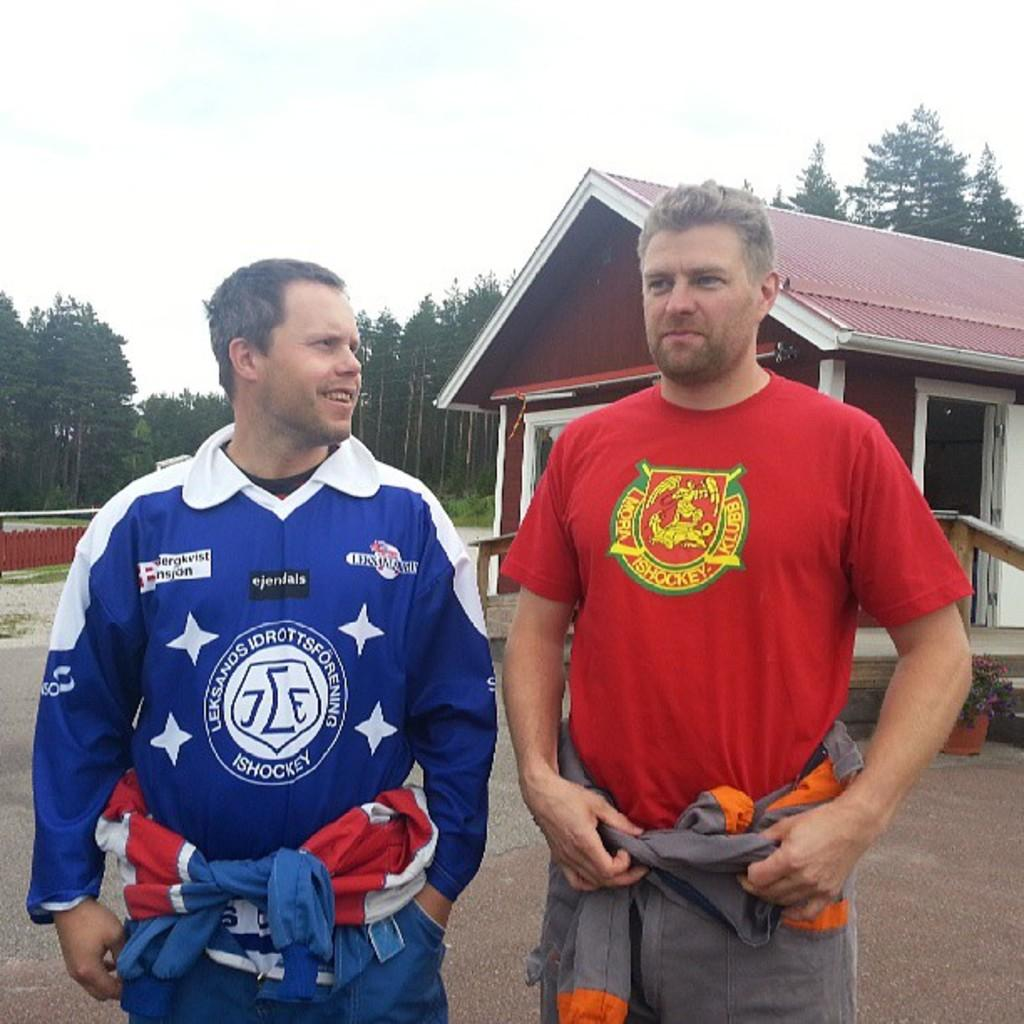<image>
Offer a succinct explanation of the picture presented. Two men are standing next to each other and the taller of the two has a Mora Ishockey Klubb shirt on. 